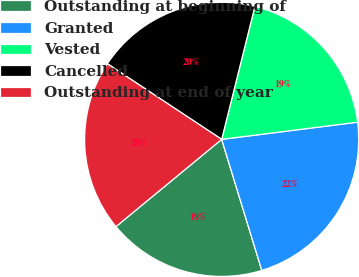Convert chart to OTSL. <chart><loc_0><loc_0><loc_500><loc_500><pie_chart><fcel>Outstanding at beginning of<fcel>Granted<fcel>Vested<fcel>Cancelled<fcel>Outstanding at end of year<nl><fcel>18.75%<fcel>22.27%<fcel>19.1%<fcel>19.6%<fcel>20.28%<nl></chart> 